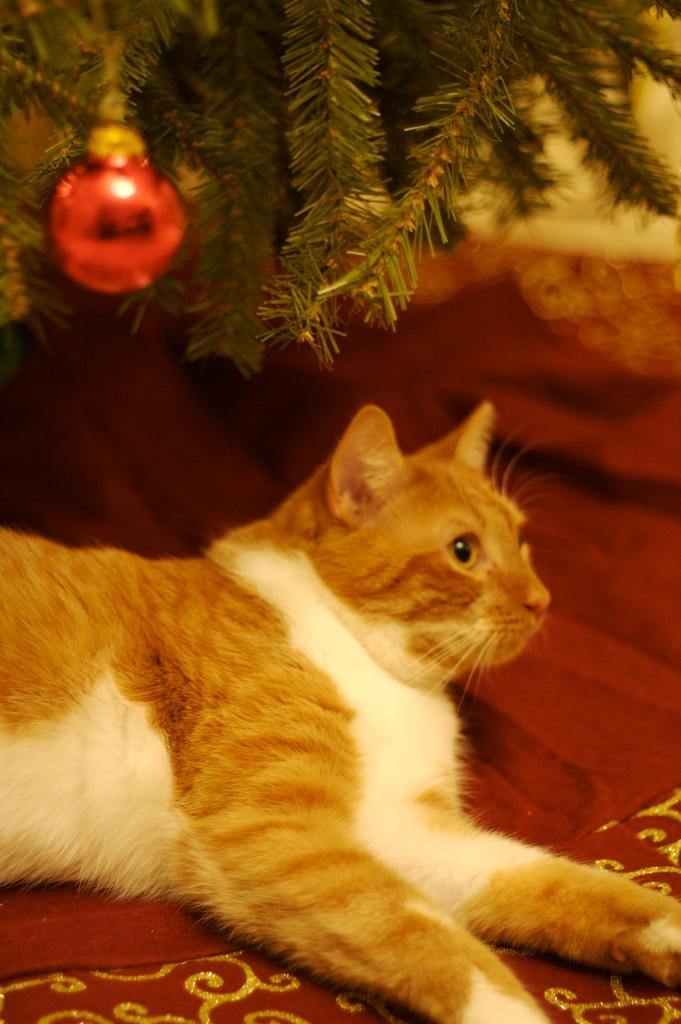What is the main subject in the foreground of the image? There is a cat in the foreground of the image. What is the cat sitting on? The cat is on a red color object. What other red object can be seen in the image? There is a red color ball in the image. How is the red color ball positioned in the image? The red color ball is hanging from a plant. What type of toothbrush is the cat using in the image? There is no toothbrush present in the image, and the cat is not using any such object. 